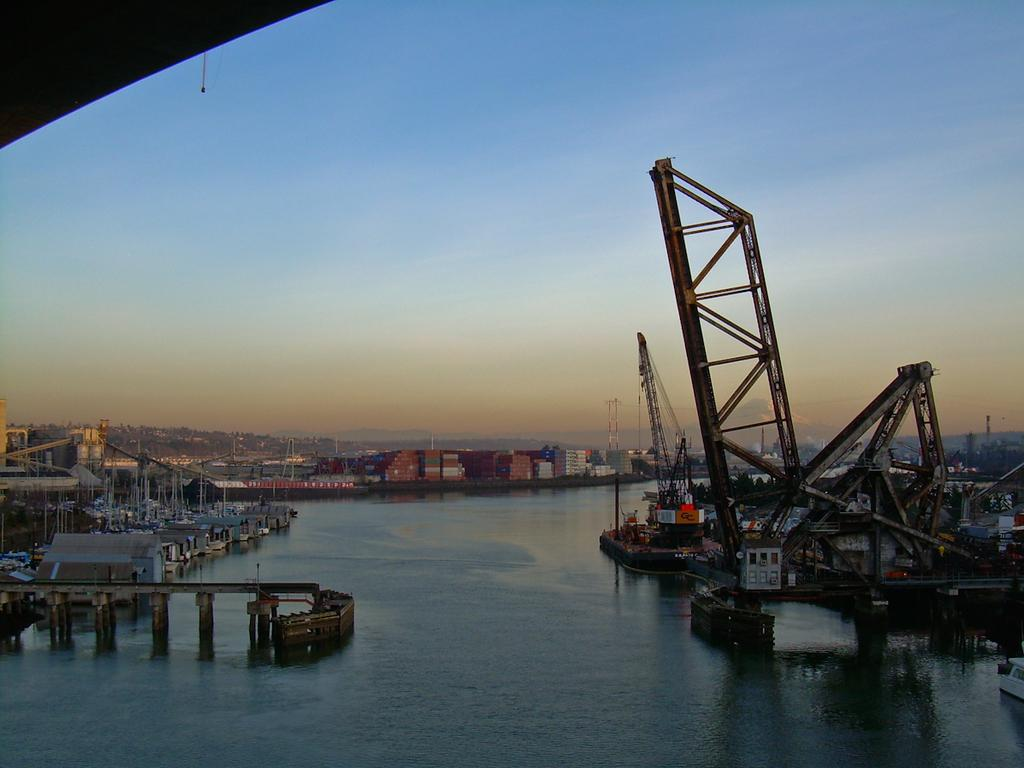What type of structures can be seen on the water in the image? There are shipyards on the water in the image. What type of transportation infrastructure is present in the image? There is a bridge in the image. What type of objects are present in the image that resemble long, thin bars? There are rods in the image. What type of tall structure can be seen in the image? There is a tower in the image. What can be seen in the background of the image? The sky is visible in the background of the image. What type of meal is being prepared in the image? There is no meal being prepared in the image; it features shipyards, a bridge, rods, a tower, and the sky. What is the tendency of the rods in the image? The image does not indicate any tendency of the rods; they are simply present in the image. 